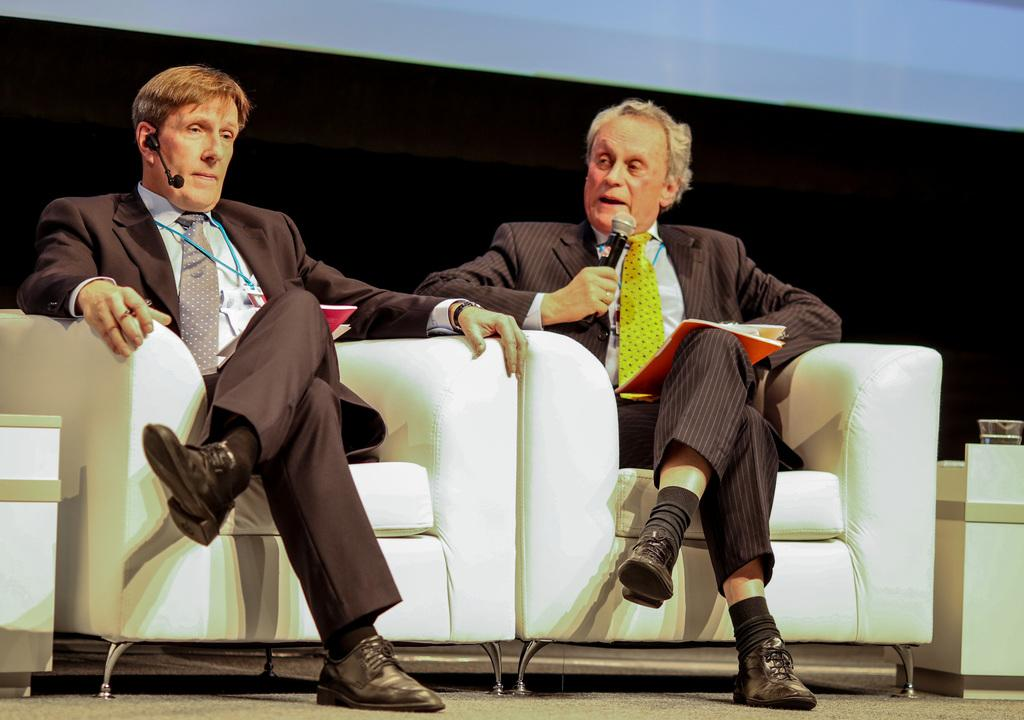How many people are in the image? There are two men in the image. What are the men doing in the image? The men are sitting on a sofa, and the second person is speaking through a mic. What are the men holding in their laps? Both men are holding books on their laps. What type of steam is coming out of the mouth of the first person in the image? There is no steam coming out of the mouth of the first person in the image. 